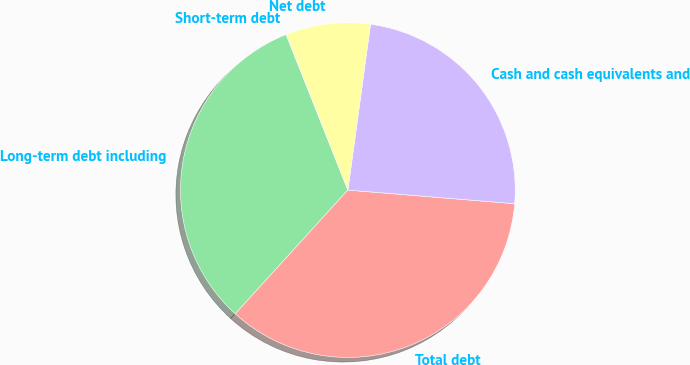Convert chart. <chart><loc_0><loc_0><loc_500><loc_500><pie_chart><fcel>Short-term debt<fcel>Long-term debt including<fcel>Total debt<fcel>Cash and cash equivalents and<fcel>Net debt<nl><fcel>0.05%<fcel>32.22%<fcel>35.45%<fcel>24.14%<fcel>8.14%<nl></chart> 